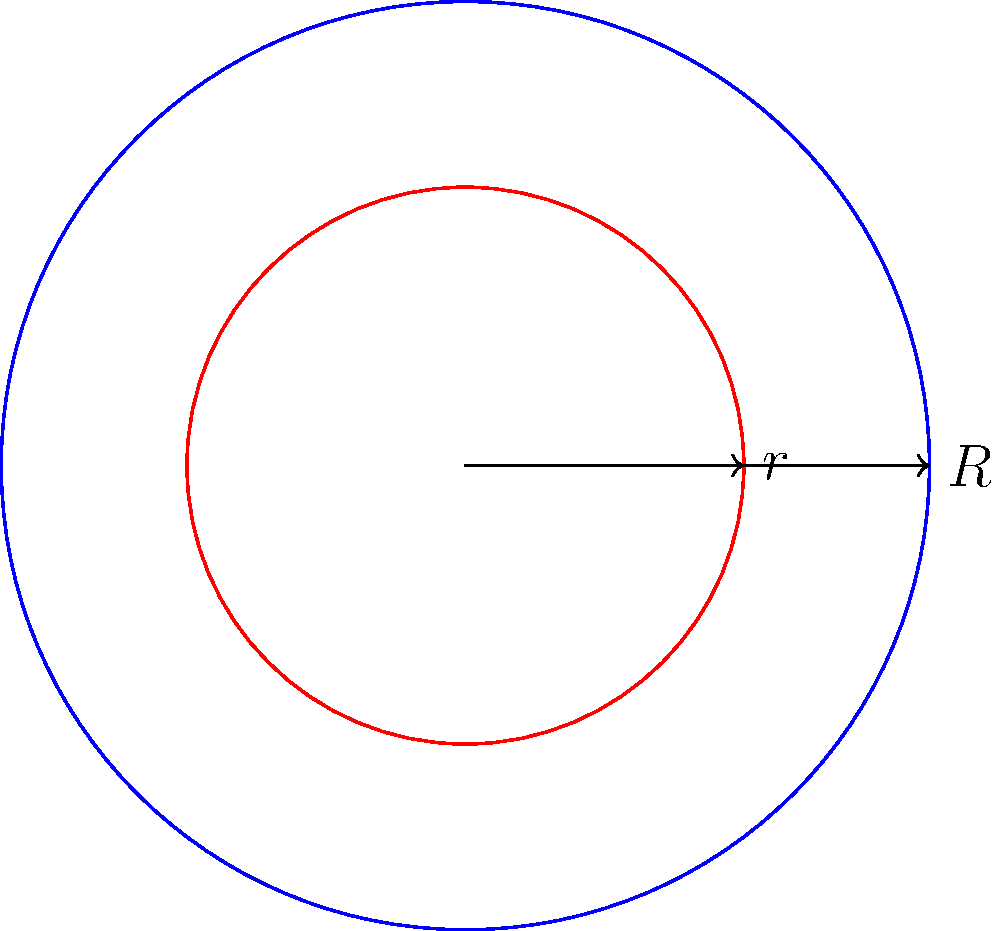In the diagram, two concentric circles are shown with radii $r$ and $R$, where $R > r$. If $R = 5$ units and $r = 3$ units, calculate the area of the region between the two circles. Express your answer in terms of $\pi$ square units. To find the area between two concentric circles, we need to:

1. Calculate the area of the larger circle (radius $R$):
   $$A_R = \pi R^2 = \pi (5^2) = 25\pi$$

2. Calculate the area of the smaller circle (radius $r$):
   $$A_r = \pi r^2 = \pi (3^2) = 9\pi$$

3. Subtract the area of the smaller circle from the area of the larger circle:
   $$A_{between} = A_R - A_r = 25\pi - 9\pi = 16\pi$$

Therefore, the area of the region between the two circles is $16\pi$ square units.
Answer: $16\pi$ square units 